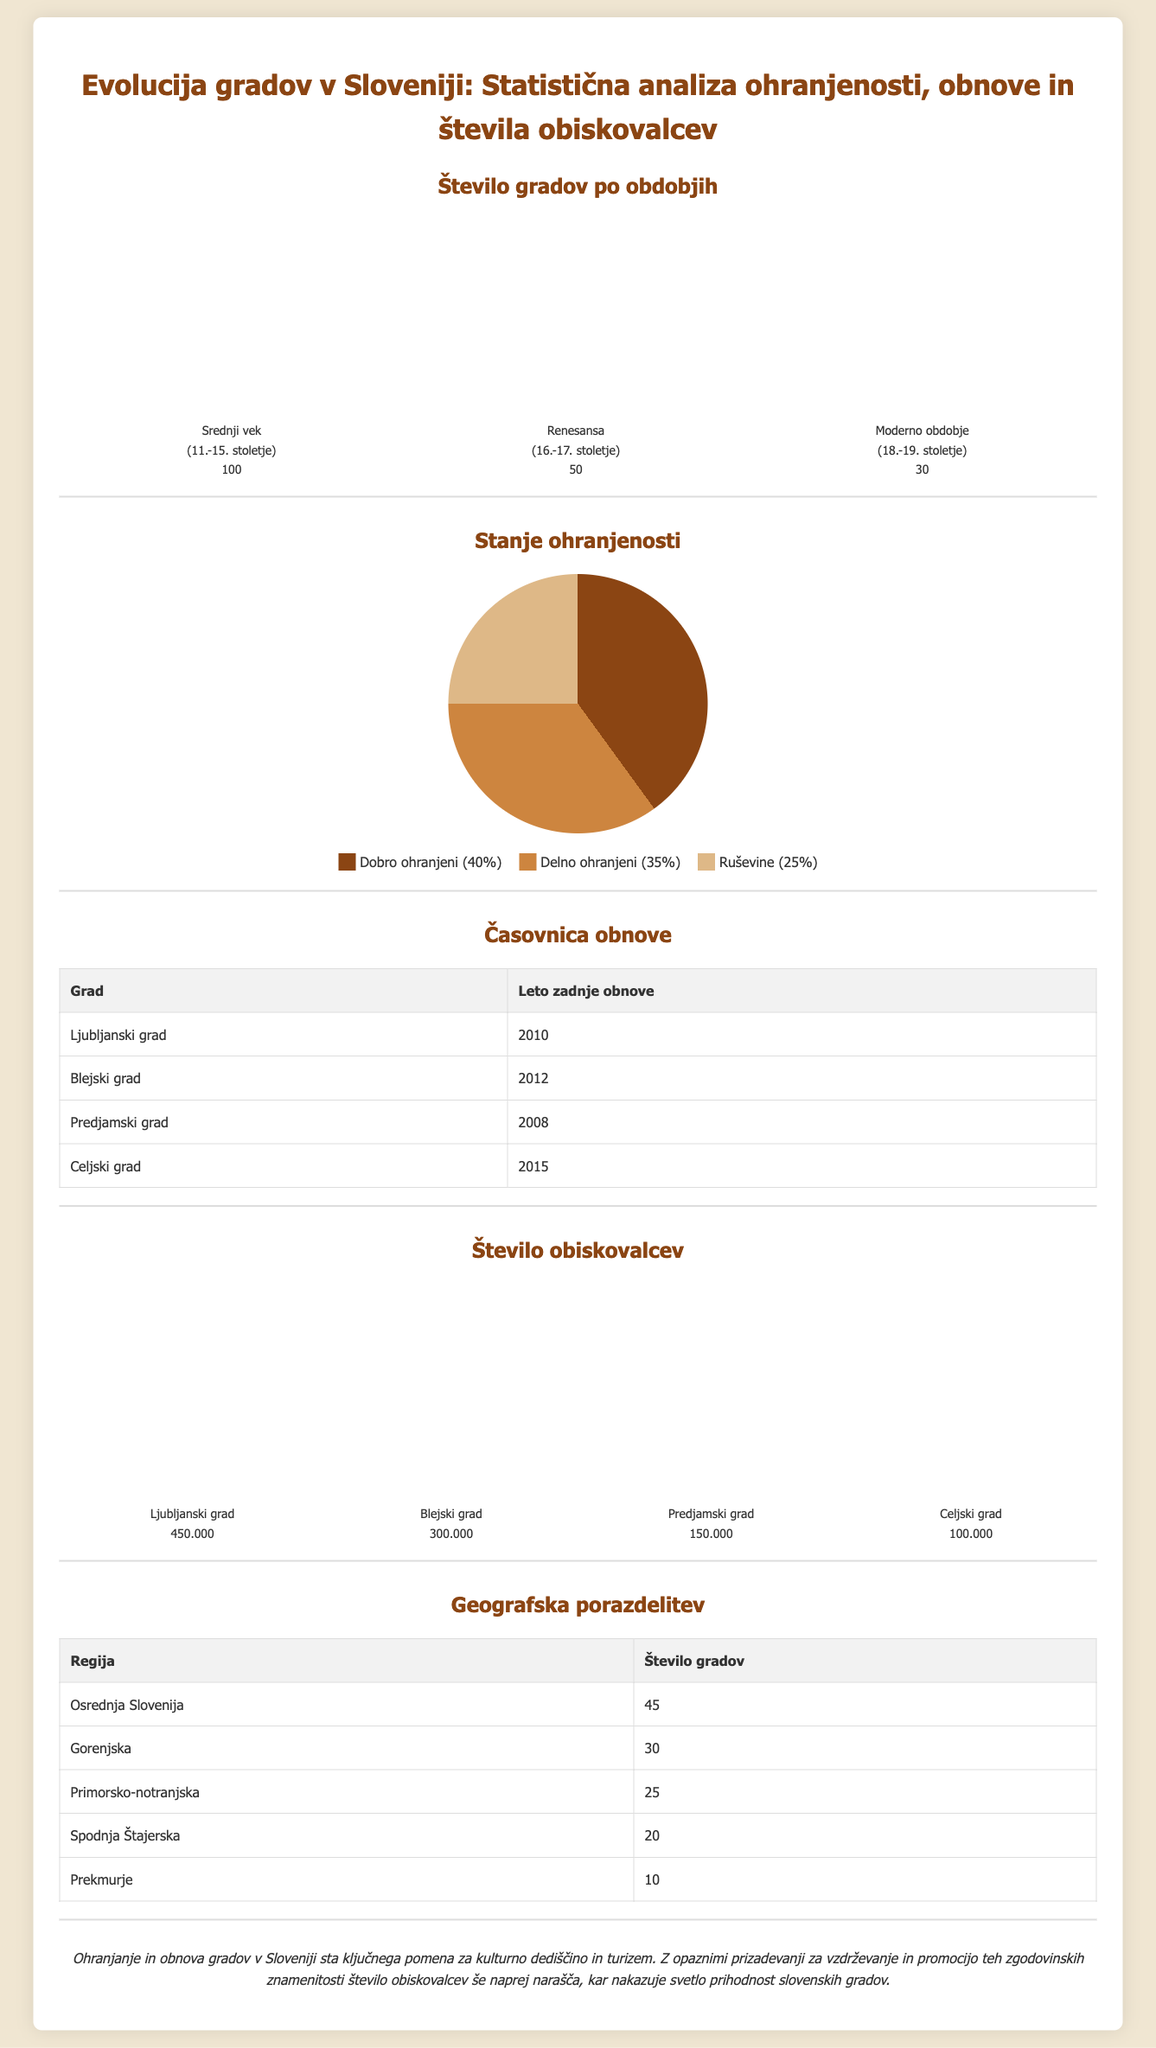what is the total number of castles from the medieval period? The document states that there are 100 castles from the medieval period (11th-15th century).
Answer: 100 what percentage of castles are well-preserved? The infographic indicates that 40% of castles are well preserved.
Answer: 40% which castle had its last renovation in 2012? The document lists Blejski grad as the castle that had its last renovation in 2012.
Answer: Blejski grad how many castles are there in Gorenjska region? The table presents that there are 30 castles in Gorenjska region.
Answer: 30 which castle has the highest number of visitors? According to the information, Ljubljanski grad has the highest number of visitors with 450,000.
Answer: Ljubljanski grad what is the total number of partially preserved castles? The document states that 35% of castles are partially preserved; without a specific number, the total cannot be calculated directly, thus it asks for context.
Answer: 35% which year was Celjski grad last renovated? Celjski grad was last renovated in the year 2015 according to the table in the document.
Answer: 2015 what is the total number of visitors to Predjamski grad? The infographic indicates that Predjamski grad has 150,000 visitors.
Answer: 150.000 